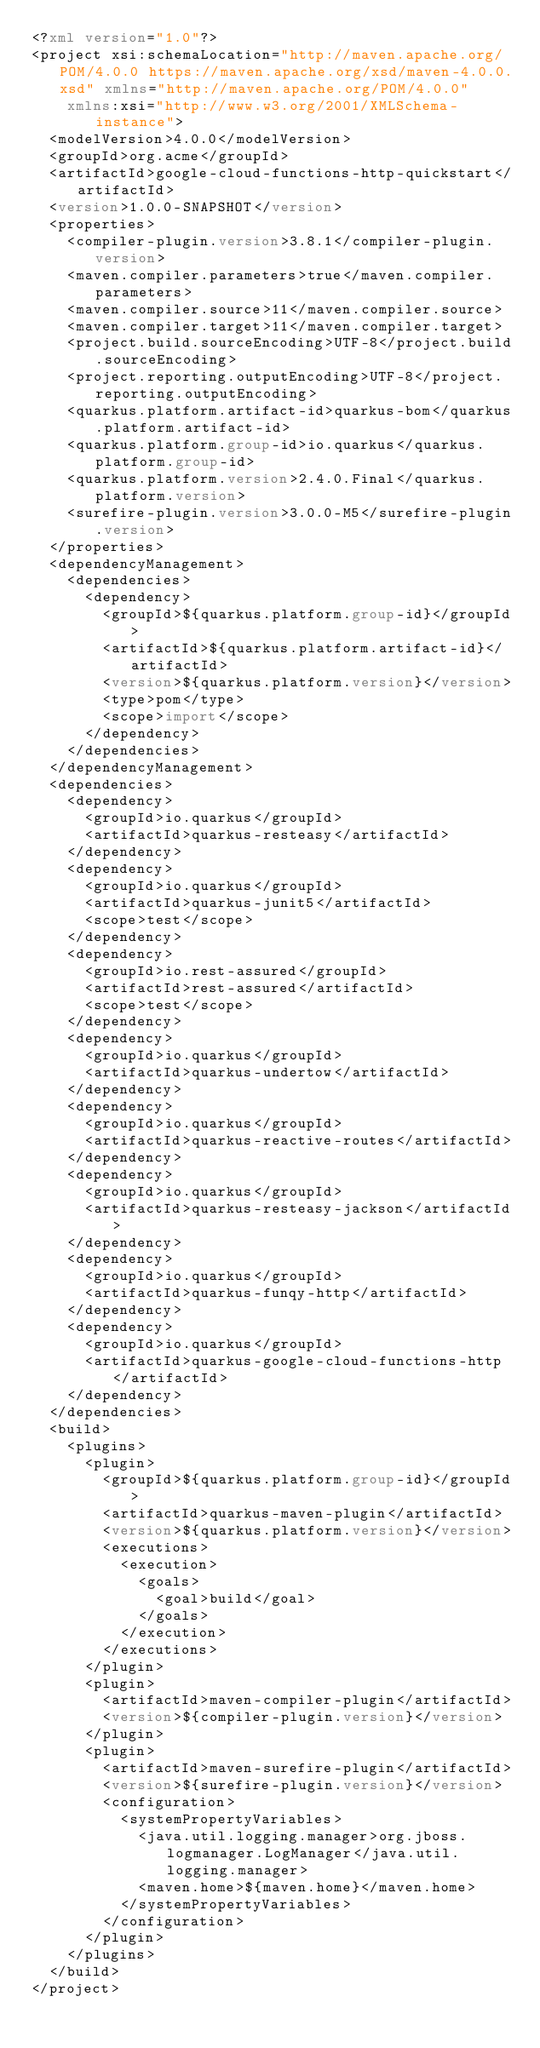<code> <loc_0><loc_0><loc_500><loc_500><_XML_><?xml version="1.0"?>
<project xsi:schemaLocation="http://maven.apache.org/POM/4.0.0 https://maven.apache.org/xsd/maven-4.0.0.xsd" xmlns="http://maven.apache.org/POM/4.0.0"
    xmlns:xsi="http://www.w3.org/2001/XMLSchema-instance">
  <modelVersion>4.0.0</modelVersion>
  <groupId>org.acme</groupId>
  <artifactId>google-cloud-functions-http-quickstart</artifactId>
  <version>1.0.0-SNAPSHOT</version>
  <properties>
    <compiler-plugin.version>3.8.1</compiler-plugin.version>
    <maven.compiler.parameters>true</maven.compiler.parameters>
    <maven.compiler.source>11</maven.compiler.source>
    <maven.compiler.target>11</maven.compiler.target>
    <project.build.sourceEncoding>UTF-8</project.build.sourceEncoding>
    <project.reporting.outputEncoding>UTF-8</project.reporting.outputEncoding>
    <quarkus.platform.artifact-id>quarkus-bom</quarkus.platform.artifact-id>
    <quarkus.platform.group-id>io.quarkus</quarkus.platform.group-id>
    <quarkus.platform.version>2.4.0.Final</quarkus.platform.version>
    <surefire-plugin.version>3.0.0-M5</surefire-plugin.version>
  </properties>
  <dependencyManagement>
    <dependencies>
      <dependency>
        <groupId>${quarkus.platform.group-id}</groupId>
        <artifactId>${quarkus.platform.artifact-id}</artifactId>
        <version>${quarkus.platform.version}</version>
        <type>pom</type>
        <scope>import</scope>
      </dependency>
    </dependencies>
  </dependencyManagement>
  <dependencies>
    <dependency>
      <groupId>io.quarkus</groupId>
      <artifactId>quarkus-resteasy</artifactId>
    </dependency>
    <dependency>
      <groupId>io.quarkus</groupId>
      <artifactId>quarkus-junit5</artifactId>
      <scope>test</scope>
    </dependency>
    <dependency>
      <groupId>io.rest-assured</groupId>
      <artifactId>rest-assured</artifactId>
      <scope>test</scope>
    </dependency>
    <dependency>
      <groupId>io.quarkus</groupId>
      <artifactId>quarkus-undertow</artifactId>
    </dependency>
    <dependency>
      <groupId>io.quarkus</groupId>
      <artifactId>quarkus-reactive-routes</artifactId>
    </dependency>
    <dependency>
      <groupId>io.quarkus</groupId>
      <artifactId>quarkus-resteasy-jackson</artifactId>
    </dependency>
    <dependency>
      <groupId>io.quarkus</groupId>
      <artifactId>quarkus-funqy-http</artifactId>
    </dependency>
    <dependency>
      <groupId>io.quarkus</groupId>
      <artifactId>quarkus-google-cloud-functions-http</artifactId>
    </dependency>
  </dependencies>
  <build>
    <plugins>
      <plugin>
        <groupId>${quarkus.platform.group-id}</groupId>
        <artifactId>quarkus-maven-plugin</artifactId>
        <version>${quarkus.platform.version}</version>
        <executions>
          <execution>
            <goals>
              <goal>build</goal>
            </goals>
          </execution>
        </executions>
      </plugin>
      <plugin>
        <artifactId>maven-compiler-plugin</artifactId>
        <version>${compiler-plugin.version}</version>
      </plugin>
      <plugin>
        <artifactId>maven-surefire-plugin</artifactId>
        <version>${surefire-plugin.version}</version>
        <configuration>
          <systemPropertyVariables>
            <java.util.logging.manager>org.jboss.logmanager.LogManager</java.util.logging.manager>
            <maven.home>${maven.home}</maven.home>
          </systemPropertyVariables>
        </configuration>
      </plugin>
    </plugins>
  </build>
</project>
</code> 